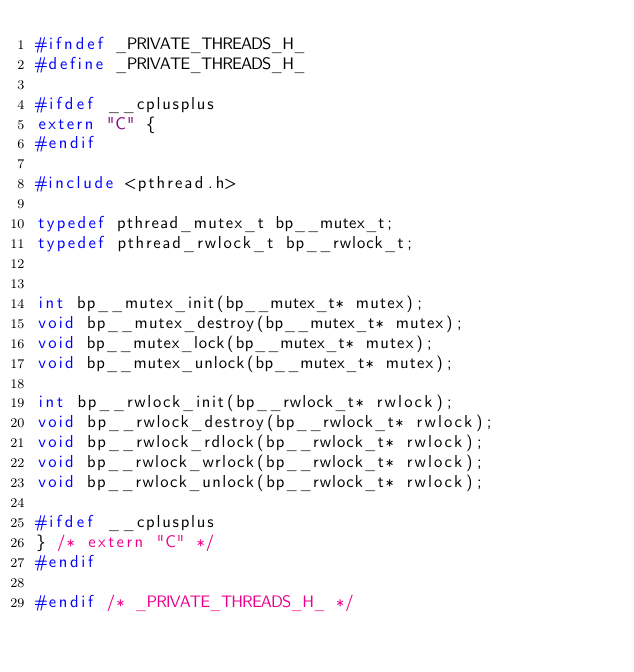Convert code to text. <code><loc_0><loc_0><loc_500><loc_500><_C_>#ifndef _PRIVATE_THREADS_H_
#define _PRIVATE_THREADS_H_

#ifdef __cplusplus
extern "C" {
#endif

#include <pthread.h>

typedef pthread_mutex_t bp__mutex_t;
typedef pthread_rwlock_t bp__rwlock_t;


int bp__mutex_init(bp__mutex_t* mutex);
void bp__mutex_destroy(bp__mutex_t* mutex);
void bp__mutex_lock(bp__mutex_t* mutex);
void bp__mutex_unlock(bp__mutex_t* mutex);

int bp__rwlock_init(bp__rwlock_t* rwlock);
void bp__rwlock_destroy(bp__rwlock_t* rwlock);
void bp__rwlock_rdlock(bp__rwlock_t* rwlock);
void bp__rwlock_wrlock(bp__rwlock_t* rwlock);
void bp__rwlock_unlock(bp__rwlock_t* rwlock);

#ifdef __cplusplus
} /* extern "C" */
#endif

#endif /* _PRIVATE_THREADS_H_ */
</code> 